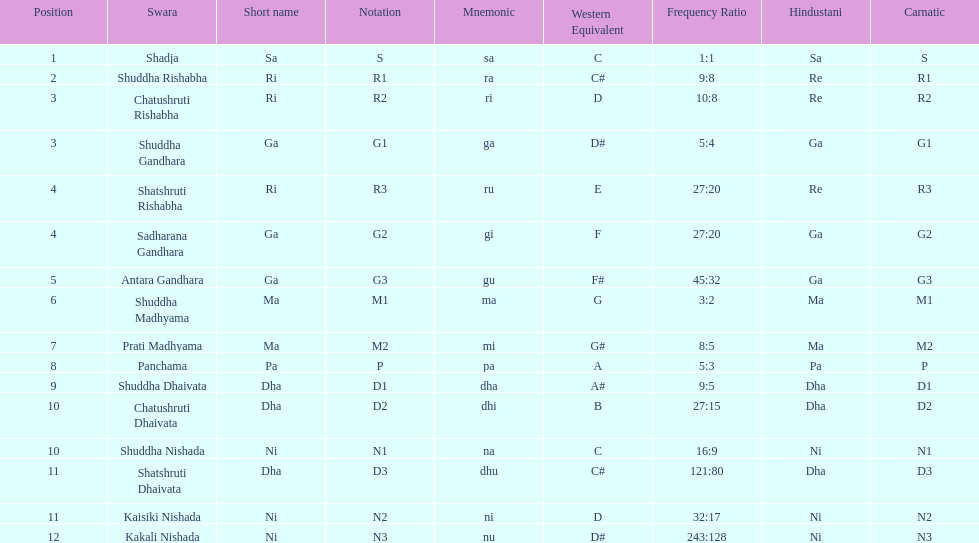What swara is above shatshruti dhaivata? Shuddha Nishada. 